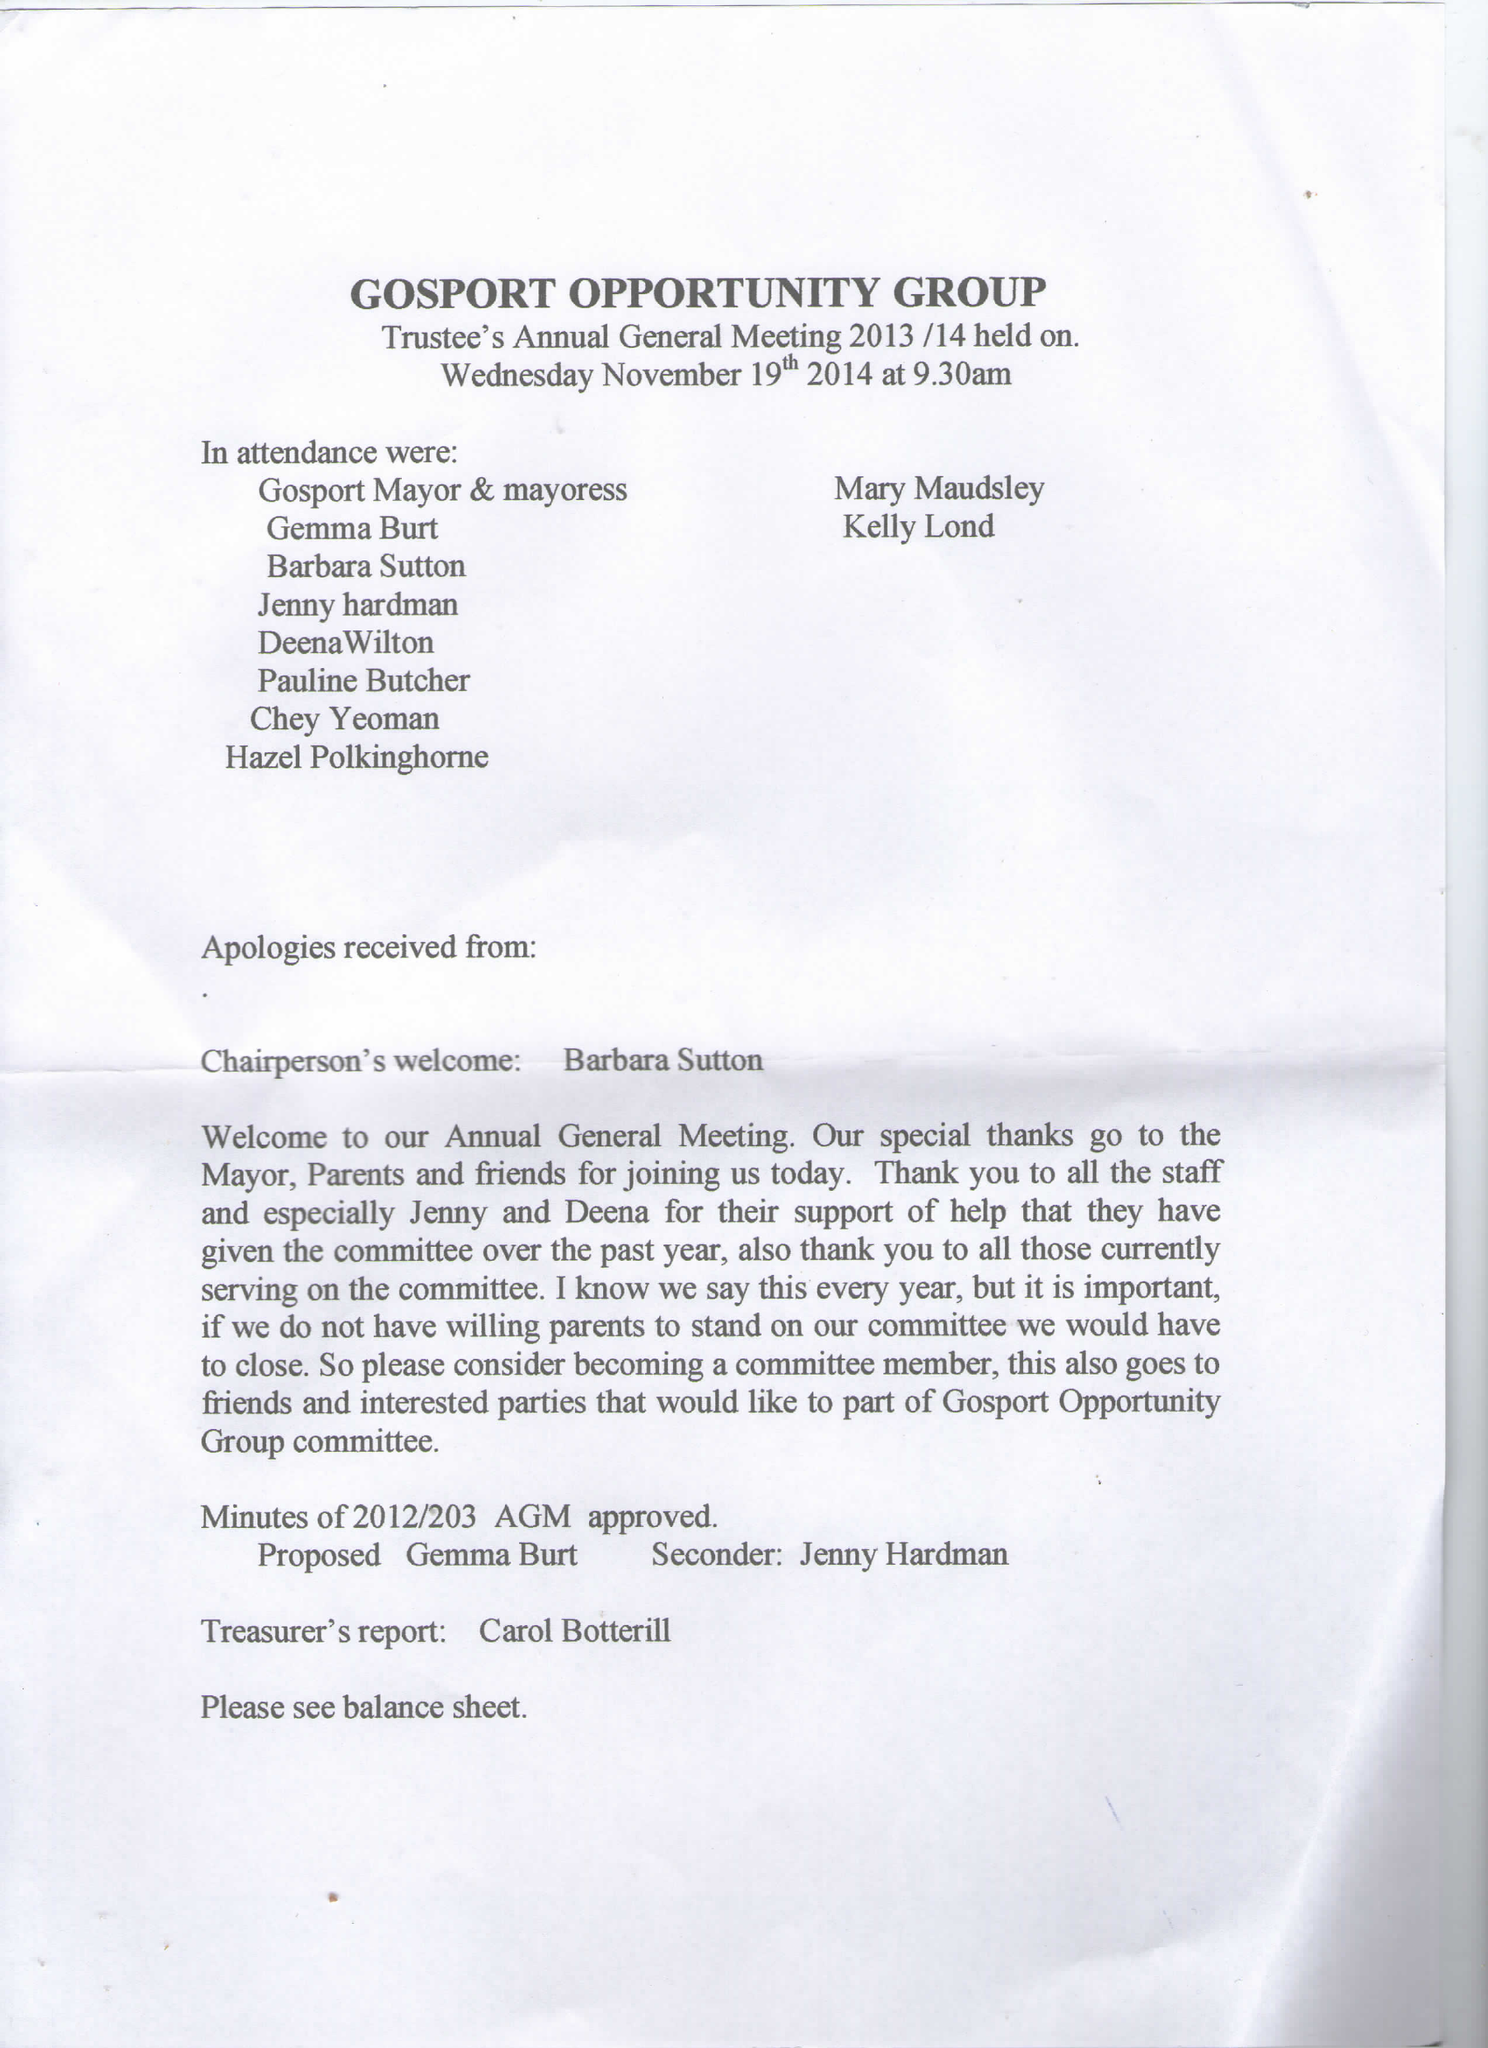What is the value for the spending_annually_in_british_pounds?
Answer the question using a single word or phrase. 74197.13 